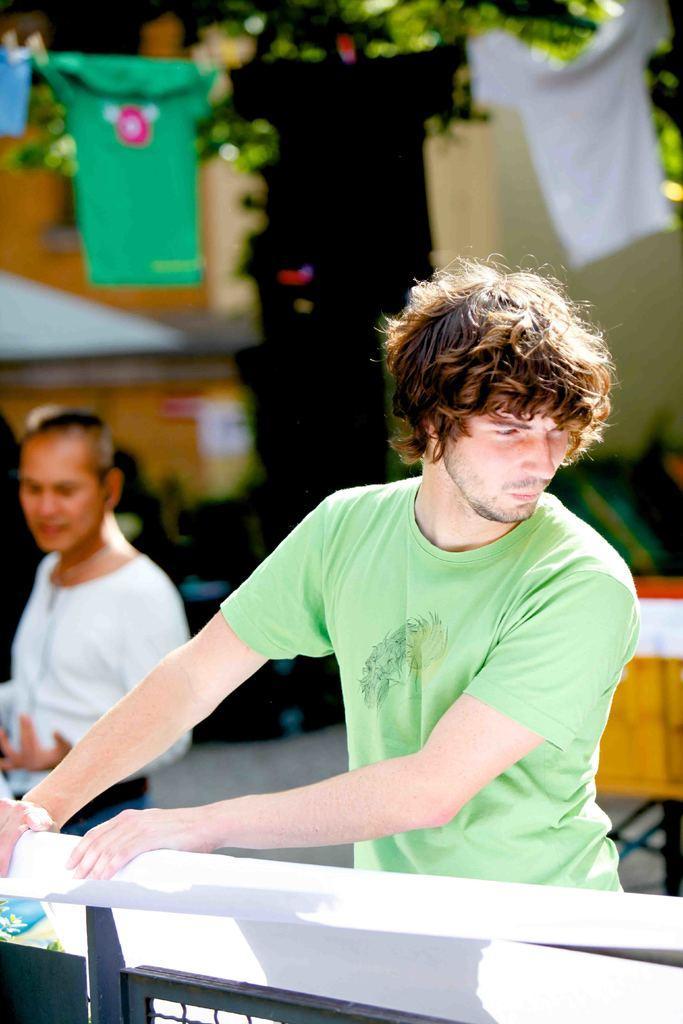Could you give a brief overview of what you see in this image? In this image there is a person wrapping a poster on a metal rod fence, behind the person there is another person standing, behind them there are clothes hanged with the rope, behind the building there is a building and there are trees and there are some objects on the surface. 